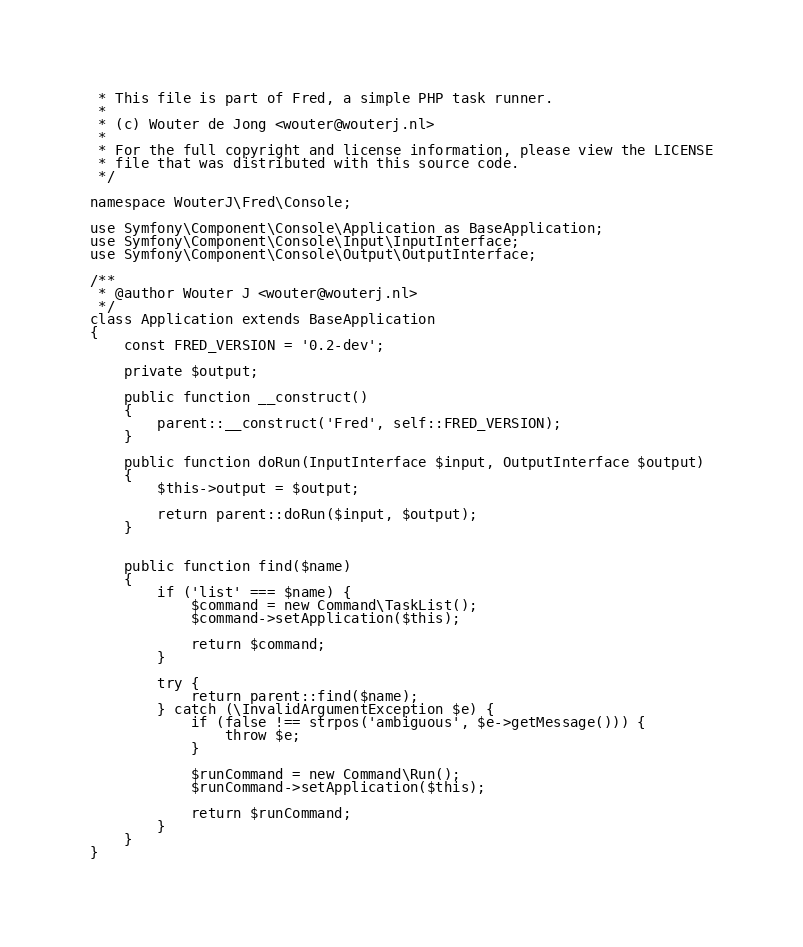<code> <loc_0><loc_0><loc_500><loc_500><_PHP_> * This file is part of Fred, a simple PHP task runner.
 *
 * (c) Wouter de Jong <wouter@wouterj.nl>
 *
 * For the full copyright and license information, please view the LICENSE
 * file that was distributed with this source code.
 */

namespace WouterJ\Fred\Console;

use Symfony\Component\Console\Application as BaseApplication;
use Symfony\Component\Console\Input\InputInterface;
use Symfony\Component\Console\Output\OutputInterface;

/**
 * @author Wouter J <wouter@wouterj.nl>
 */
class Application extends BaseApplication
{
    const FRED_VERSION = '0.2-dev';

    private $output;

    public function __construct()
    {
        parent::__construct('Fred', self::FRED_VERSION);
    }

    public function doRun(InputInterface $input, OutputInterface $output)
    {
        $this->output = $output;

        return parent::doRun($input, $output);
    }


    public function find($name)
    {
        if ('list' === $name) {
            $command = new Command\TaskList();
            $command->setApplication($this);

            return $command;
        }

        try {
            return parent::find($name);
        } catch (\InvalidArgumentException $e) {
            if (false !== strpos('ambiguous', $e->getMessage())) {
                throw $e;
            }

            $runCommand = new Command\Run();
            $runCommand->setApplication($this);

            return $runCommand;
        }
    }
}
</code> 